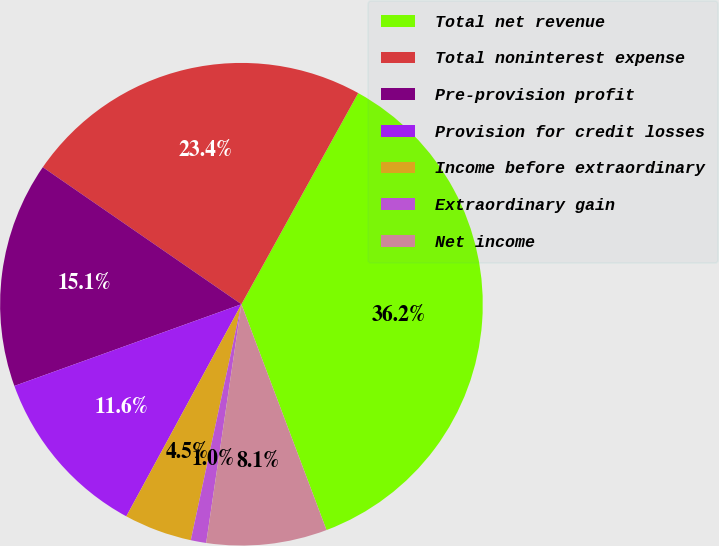<chart> <loc_0><loc_0><loc_500><loc_500><pie_chart><fcel>Total net revenue<fcel>Total noninterest expense<fcel>Pre-provision profit<fcel>Provision for credit losses<fcel>Income before extraordinary<fcel>Extraordinary gain<fcel>Net income<nl><fcel>36.23%<fcel>23.43%<fcel>15.11%<fcel>11.59%<fcel>4.55%<fcel>1.03%<fcel>8.07%<nl></chart> 